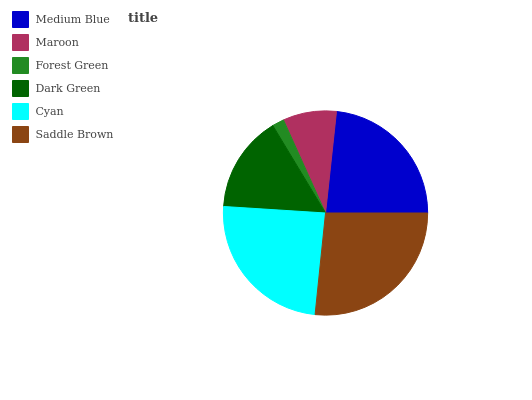Is Forest Green the minimum?
Answer yes or no. Yes. Is Saddle Brown the maximum?
Answer yes or no. Yes. Is Maroon the minimum?
Answer yes or no. No. Is Maroon the maximum?
Answer yes or no. No. Is Medium Blue greater than Maroon?
Answer yes or no. Yes. Is Maroon less than Medium Blue?
Answer yes or no. Yes. Is Maroon greater than Medium Blue?
Answer yes or no. No. Is Medium Blue less than Maroon?
Answer yes or no. No. Is Medium Blue the high median?
Answer yes or no. Yes. Is Dark Green the low median?
Answer yes or no. Yes. Is Dark Green the high median?
Answer yes or no. No. Is Forest Green the low median?
Answer yes or no. No. 